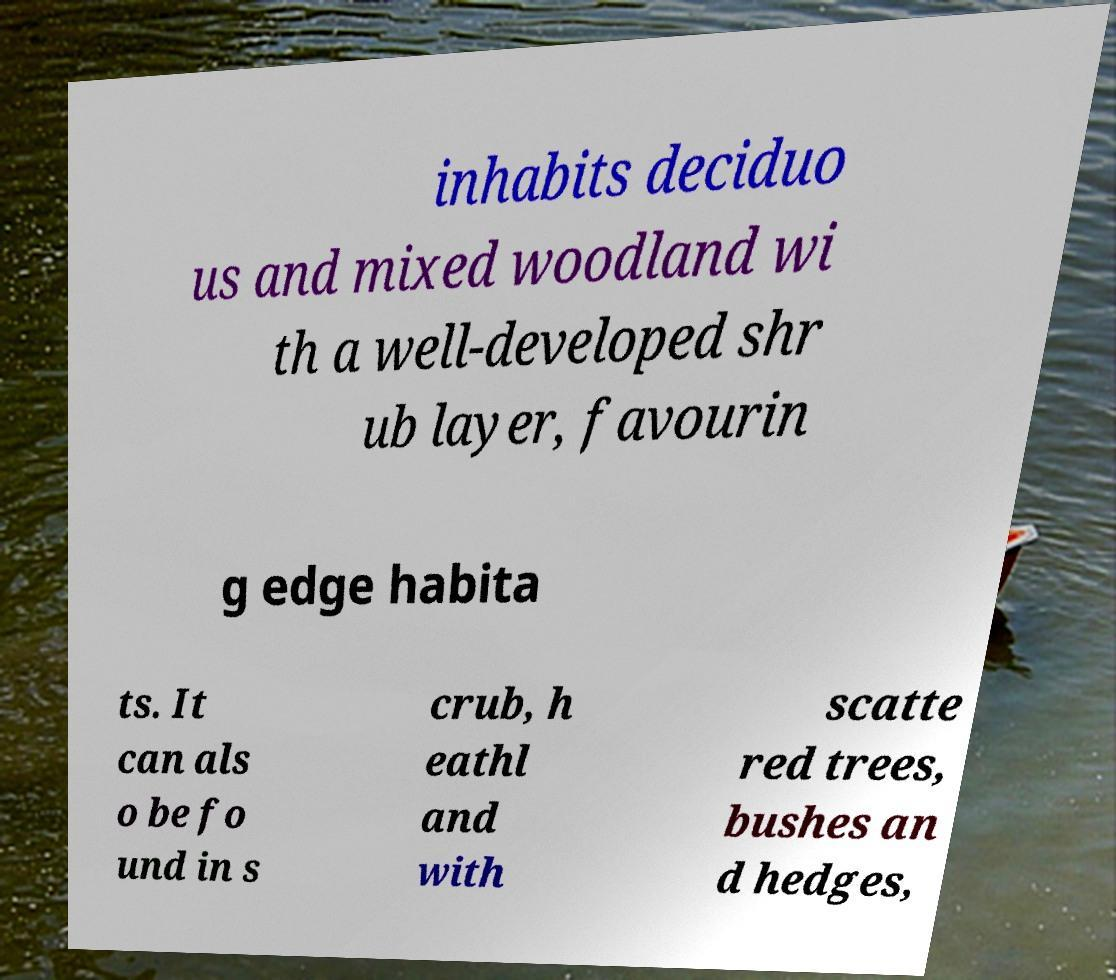Can you read and provide the text displayed in the image?This photo seems to have some interesting text. Can you extract and type it out for me? inhabits deciduo us and mixed woodland wi th a well-developed shr ub layer, favourin g edge habita ts. It can als o be fo und in s crub, h eathl and with scatte red trees, bushes an d hedges, 